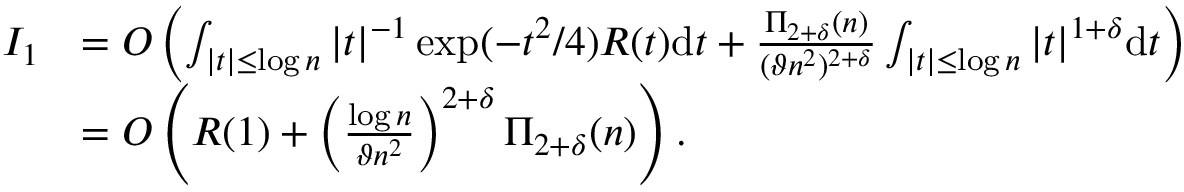<formula> <loc_0><loc_0><loc_500><loc_500>\begin{array} { r l } { I _ { 1 } } & { = O \left ( \int _ { | t | \leq \log n } | t | ^ { - 1 } \exp ( - t ^ { 2 } / 4 ) R ( t ) d t + \frac { \Pi _ { 2 + \delta } ( n ) } { ( \vartheta n ^ { 2 } ) ^ { 2 + \delta } } \int _ { | t | \leq \log n } | t | ^ { 1 + \delta } d t \right ) } \\ & { = O \left ( R ( 1 ) + \left ( \frac { \log n } { \vartheta n ^ { 2 } } \right ) ^ { 2 + \delta } \Pi _ { 2 + \delta } ( n ) \right ) . } \end{array}</formula> 